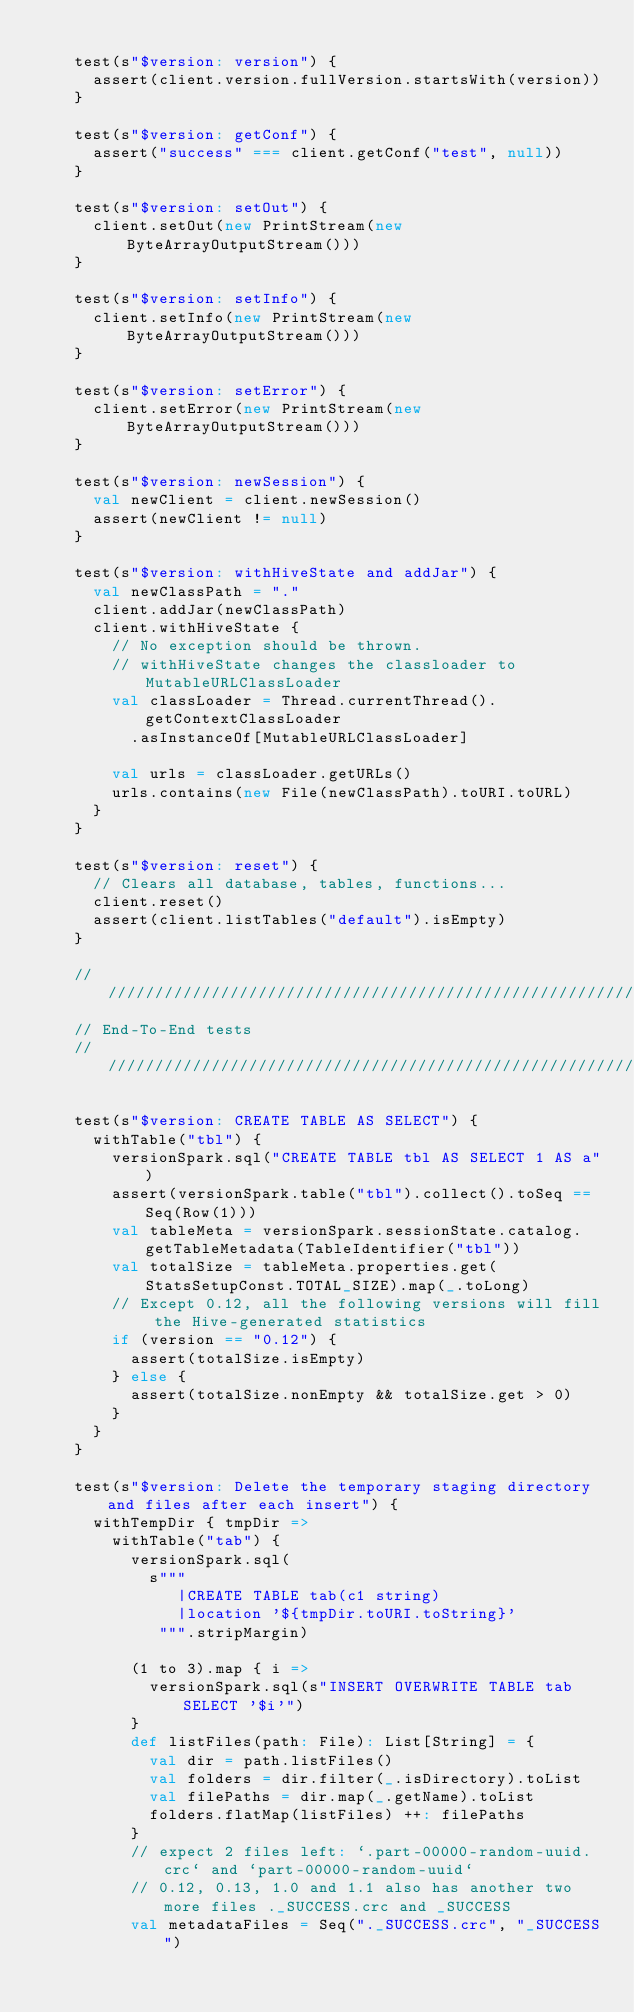Convert code to text. <code><loc_0><loc_0><loc_500><loc_500><_Scala_>
    test(s"$version: version") {
      assert(client.version.fullVersion.startsWith(version))
    }

    test(s"$version: getConf") {
      assert("success" === client.getConf("test", null))
    }

    test(s"$version: setOut") {
      client.setOut(new PrintStream(new ByteArrayOutputStream()))
    }

    test(s"$version: setInfo") {
      client.setInfo(new PrintStream(new ByteArrayOutputStream()))
    }

    test(s"$version: setError") {
      client.setError(new PrintStream(new ByteArrayOutputStream()))
    }

    test(s"$version: newSession") {
      val newClient = client.newSession()
      assert(newClient != null)
    }

    test(s"$version: withHiveState and addJar") {
      val newClassPath = "."
      client.addJar(newClassPath)
      client.withHiveState {
        // No exception should be thrown.
        // withHiveState changes the classloader to MutableURLClassLoader
        val classLoader = Thread.currentThread().getContextClassLoader
          .asInstanceOf[MutableURLClassLoader]

        val urls = classLoader.getURLs()
        urls.contains(new File(newClassPath).toURI.toURL)
      }
    }

    test(s"$version: reset") {
      // Clears all database, tables, functions...
      client.reset()
      assert(client.listTables("default").isEmpty)
    }

    ///////////////////////////////////////////////////////////////////////////
    // End-To-End tests
    ///////////////////////////////////////////////////////////////////////////

    test(s"$version: CREATE TABLE AS SELECT") {
      withTable("tbl") {
        versionSpark.sql("CREATE TABLE tbl AS SELECT 1 AS a")
        assert(versionSpark.table("tbl").collect().toSeq == Seq(Row(1)))
        val tableMeta = versionSpark.sessionState.catalog.getTableMetadata(TableIdentifier("tbl"))
        val totalSize = tableMeta.properties.get(StatsSetupConst.TOTAL_SIZE).map(_.toLong)
        // Except 0.12, all the following versions will fill the Hive-generated statistics
        if (version == "0.12") {
          assert(totalSize.isEmpty)
        } else {
          assert(totalSize.nonEmpty && totalSize.get > 0)
        }
      }
    }

    test(s"$version: Delete the temporary staging directory and files after each insert") {
      withTempDir { tmpDir =>
        withTable("tab") {
          versionSpark.sql(
            s"""
               |CREATE TABLE tab(c1 string)
               |location '${tmpDir.toURI.toString}'
             """.stripMargin)

          (1 to 3).map { i =>
            versionSpark.sql(s"INSERT OVERWRITE TABLE tab SELECT '$i'")
          }
          def listFiles(path: File): List[String] = {
            val dir = path.listFiles()
            val folders = dir.filter(_.isDirectory).toList
            val filePaths = dir.map(_.getName).toList
            folders.flatMap(listFiles) ++: filePaths
          }
          // expect 2 files left: `.part-00000-random-uuid.crc` and `part-00000-random-uuid`
          // 0.12, 0.13, 1.0 and 1.1 also has another two more files ._SUCCESS.crc and _SUCCESS
          val metadataFiles = Seq("._SUCCESS.crc", "_SUCCESS")</code> 